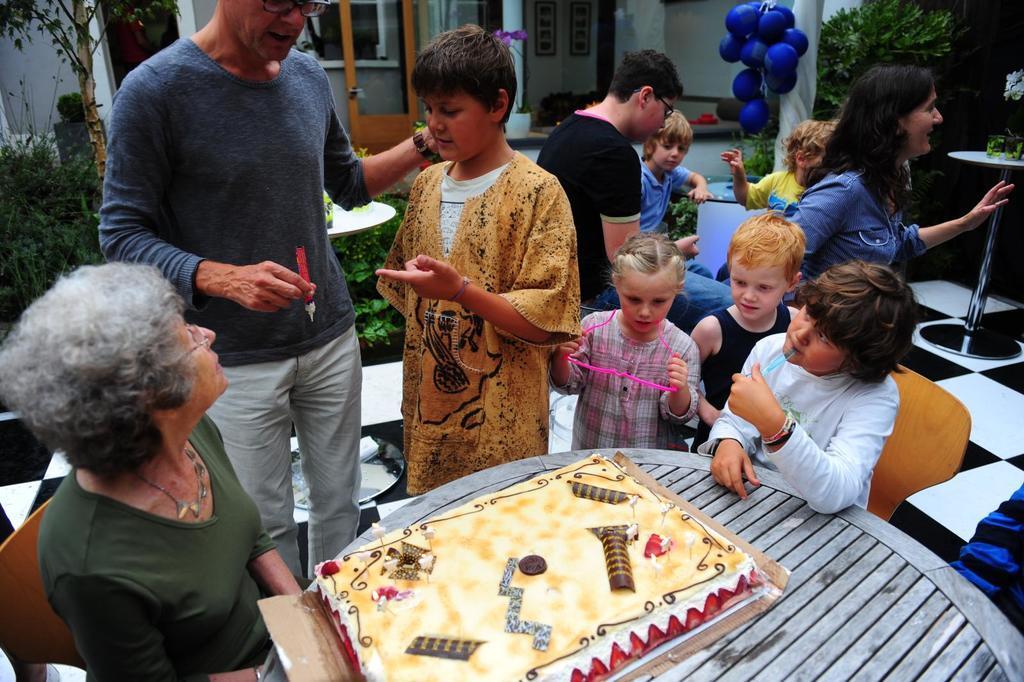In one or two sentences, can you explain what this image depicts? There are many people in this picture. There are some children too. A old woman is sitting in the chair in front of a table on which a cake is placed. In the background there are some balloons, trees and a house here. 